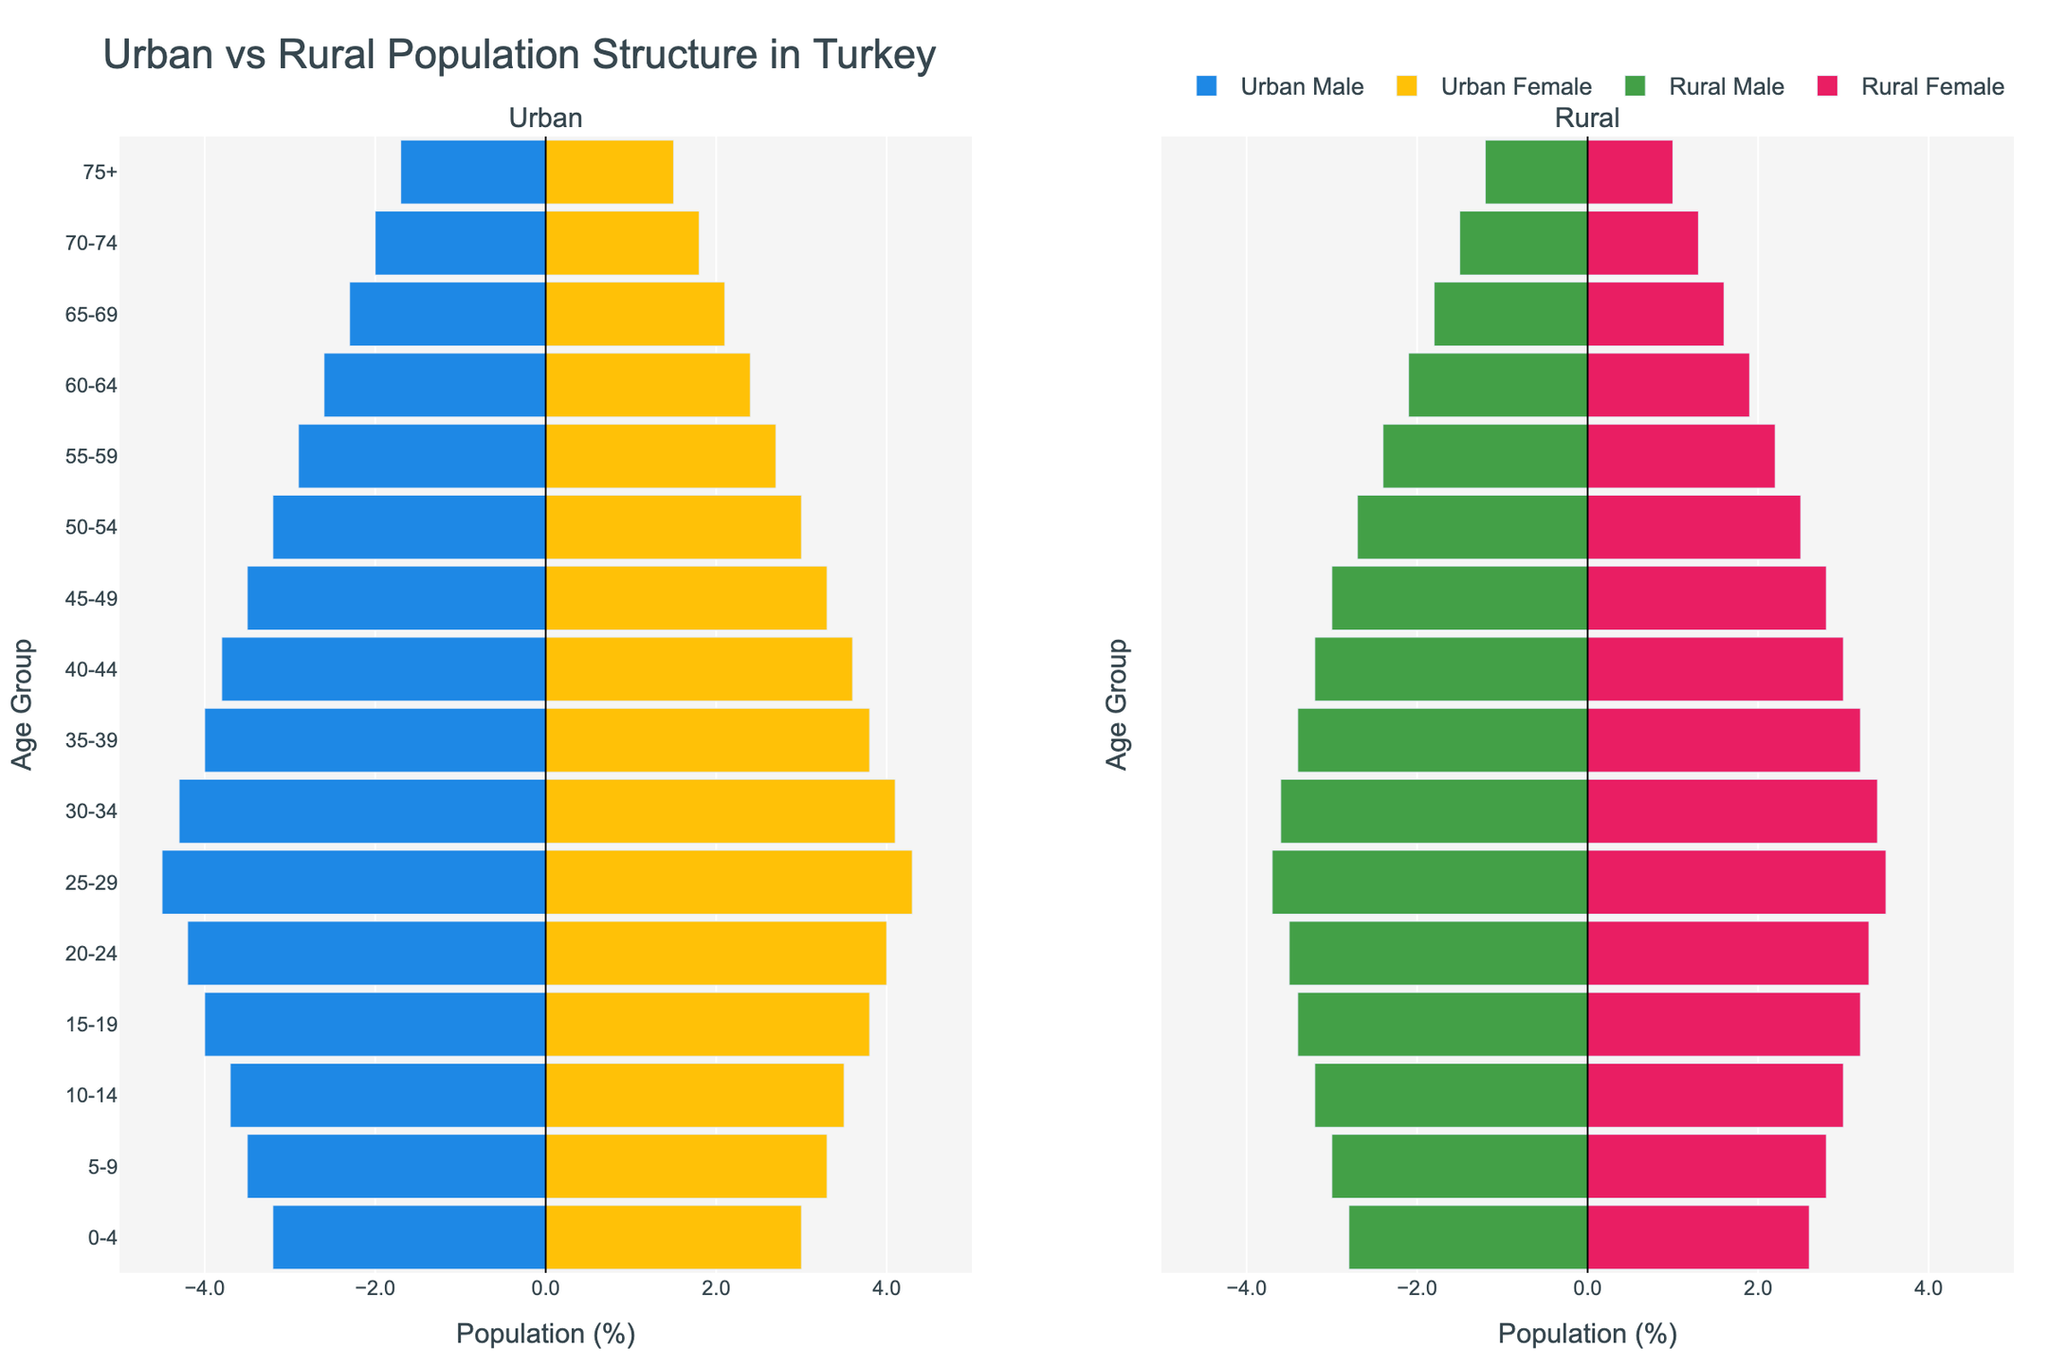What is the title of the figure? The title is typically positioned at the top of the figure and provides a summary of what the figure is about. In this case, it reads 'Urban vs Rural Population Structure in Turkey'.
Answer: Urban vs Rural Population Structure in Turkey Which side of the figure represents the urban population? The figure is divided into two subplots. The subplot on the left is titled 'Urban', indicating that it represents the urban population.
Answer: Left What age group has the highest percentage of urban males? By examining the bars for urban males (blue bars) on the left subplot, the longest bar appears for the age group 25-29.
Answer: 25-29 How does the population percentage of rural females aged 60-64 compare to urban females of the same age group? Looking at the lengths of the pink bar for rural females and yellow bar for urban females in the 60-64 age group, the rural female bar (approximately 1.9%) is shorter than the urban female bar (approximately 2.4%).
Answer: Urban females have a higher percentage What is the total percentage of the population aged 75+ in rural areas? Adding the percentages of rural males and females aged 75+, (-1.2%) + 1.0%, provides 2.2% of the population.
Answer: 2.2% In which age group do the urban male and female populations show the same percentage? By observing the lengths of blue and yellow bars in the urban subplot, both bars in the 0-4 age group are equal, with urban males at -3.2% and urban females at 3.0%.
Answer: 0-4 Which population (urban or rural) has a higher percentage of people in the age group 20-24? Comparing the lengths of blue and green bars for males and yellow and pink bars for females in the 20-24 age group, urban has a higher percentage for both genders.
Answer: Urban What is the difference in population percentage between urban and rural males aged 30-34? The urban males aged 30-34 have -4.3%, while rural males have -3.6%. The difference is 4.3% - 3.6% = 0.7%.
Answer: 0.7% What trend do you notice in the percentage of females as they age in rural areas? Observing the pink bars for rural females, the percentage decreases progressively with age, indicating a downward trend.
Answer: Decreasing trend What is the average percentage of the urban female population across all age groups? Sum the percentages for urban females (3.0+3.3+3.5+3.8+4.0+4.3+4.1+3.8+3.6+3.3+3.0+2.7+2.4+2.1+1.8+1.5 = 48.6), then divide by the number of age groups (16). 48.6 / 16 = 3.04%.
Answer: 3.04% 